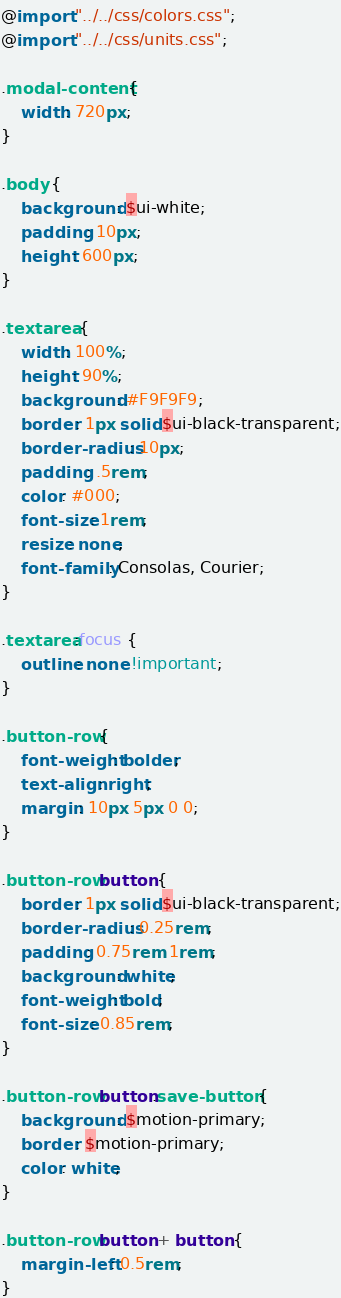Convert code to text. <code><loc_0><loc_0><loc_500><loc_500><_CSS_>@import "../../css/colors.css";
@import "../../css/units.css";

.modal-content {
    width: 720px;
}

.body {
    background: $ui-white;
    padding: 10px;
    height: 600px;
}

.textarea {
    width: 100%;
    height: 90%;
    background: #F9F9F9;
    border: 1px solid $ui-black-transparent;
    border-radius: 10px;
    padding: .5rem;
    color: #000;
    font-size: 1rem;
    resize: none;
    font-family: Consolas, Courier;
}

.textarea:focus {
    outline: none !important;
}

.button-row {
    font-weight: bolder;
    text-align: right;
    margin: 10px 5px 0 0;
}

.button-row button {
    border: 1px solid $ui-black-transparent;
    border-radius: 0.25rem;
    padding: 0.75rem 1rem;
    background: white;
    font-weight: bold;
    font-size: 0.85rem;
}

.button-row button.save-button {
    background: $motion-primary;
    border: $motion-primary;
    color: white;
}

.button-row button + button {
    margin-left: 0.5rem;
}
</code> 